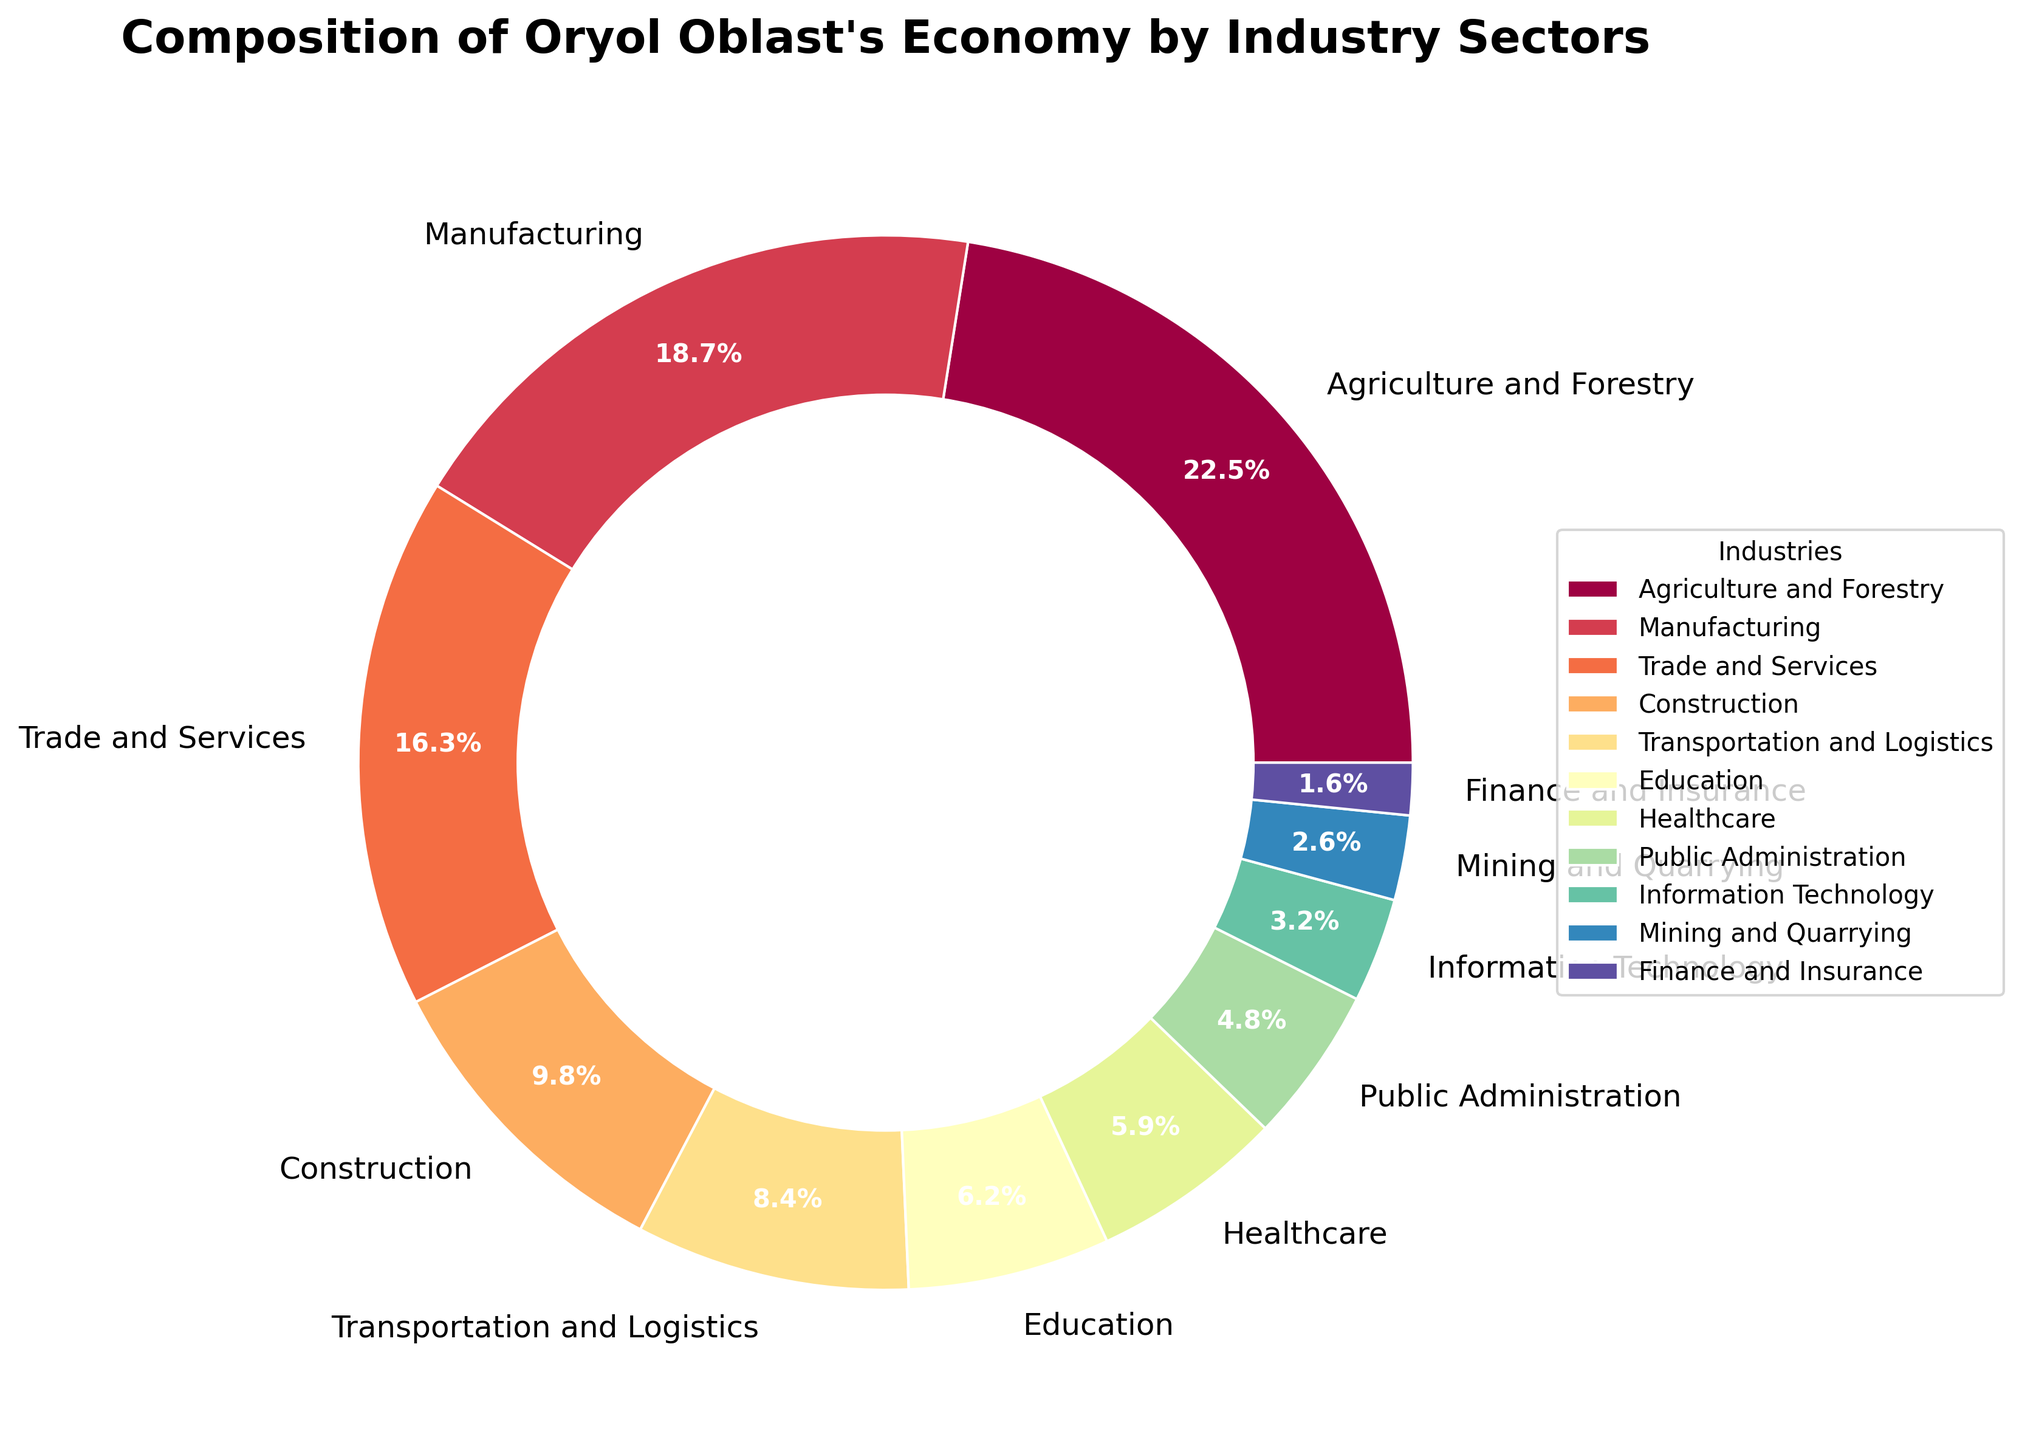Which industry sector contributes the largest percentage to Oryol Oblast's economy? The chart shows different industry sectors with corresponding percentages. By identifying the sector with the highest percentage, we determine that Agriculture and Forestry has the largest contribution at 22.5%.
Answer: Agriculture and Forestry How much more does the Agriculture and Forestry sector contribute compared to the Manufacturing sector? From the chart, Agriculture and Forestry contributes 22.5% and Manufacturing 18.7%. The difference is 22.5% - 18.7%.
Answer: 3.8% What is the combined percentage of Trade and Services, Construction, and Transportation and Logistics sectors? Add the percentages of these sectors: Trade and Services (16.3%) + Construction (9.8%) + Transportation and Logistics (8.4%).
Answer: 34.5% Which industry sectors contribute less than 5% each to the economy? By scanning the chart, the sectors contributing less than 5% are Public Administration, Information Technology, Mining and Quarrying, and Finance and Insurance.
Answer: Four sectors Is the contribution of the Education sector greater than the Healthcare sector? Compare the percentages from the chart: Education is 6.2% and Healthcare is 5.9%. Since 6.2% > 5.9%, Education contributes more.
Answer: Yes What is the percentage difference between the smallest and the largest contributing sectors? The smallest contributing sector is Finance and Insurance (1.6%) and the largest is Agriculture and Forestry (22.5%). The difference is 22.5% - 1.6%.
Answer: 20.9% For every 1% contribution by the Public Administration sector, how much does the Manufacturing sector contribute? Divide the Manufacturing percentage by the Public Administration percentage: 18.7% / 4.8%. This gives approximately 3.9.
Answer: 3.9 Which sectors together contribute exactly 47.3% to the economy? By summing the percentages of various sectors, Trade and Services (16.3%), Construction (9.8%), Transportation and Logistics (8.4%), and Education (6.2%) together add up to 47.3%.
Answer: Four sectors What’s the average contribution of the Agriculture and Forestry, Manufacturing, and Trade and Services sectors? Sum these sectors’ contributions: 22.5% + 18.7% + 16.3%, then divide by 3. The total is 57.5%, and dividing gives an average of 57.5% / 3.
Answer: 19.17% Which sector uses a purple color shade in the pie chart? Visually identifying the color shades, Mining and Quarrying is shaded in purple.
Answer: Mining and Quarrying 